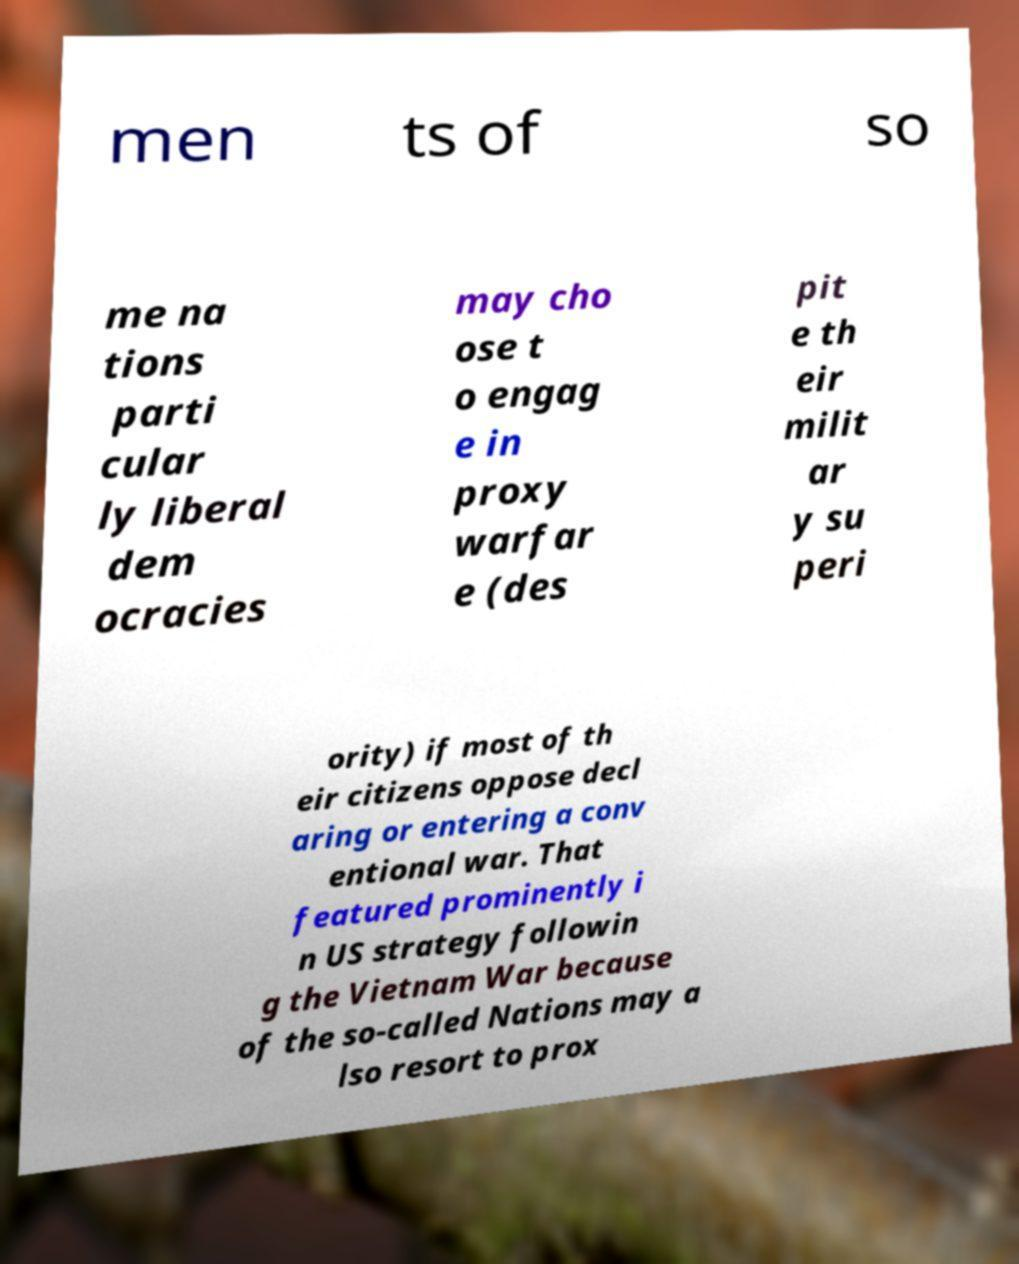Could you assist in decoding the text presented in this image and type it out clearly? men ts of so me na tions parti cular ly liberal dem ocracies may cho ose t o engag e in proxy warfar e (des pit e th eir milit ar y su peri ority) if most of th eir citizens oppose decl aring or entering a conv entional war. That featured prominently i n US strategy followin g the Vietnam War because of the so-called Nations may a lso resort to prox 